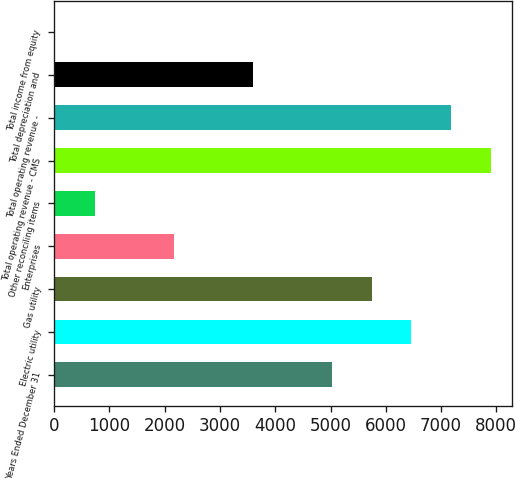Convert chart to OTSL. <chart><loc_0><loc_0><loc_500><loc_500><bar_chart><fcel>Years Ended December 31<fcel>Electric utility<fcel>Gas utility<fcel>Enterprises<fcel>Other reconciling items<fcel>Total operating revenue - CMS<fcel>Total operating revenue -<fcel>Total depreciation and<fcel>Total income from equity<nl><fcel>5029.8<fcel>6462.6<fcel>5746.2<fcel>2164.2<fcel>731.4<fcel>7895.4<fcel>7179<fcel>3597<fcel>15<nl></chart> 